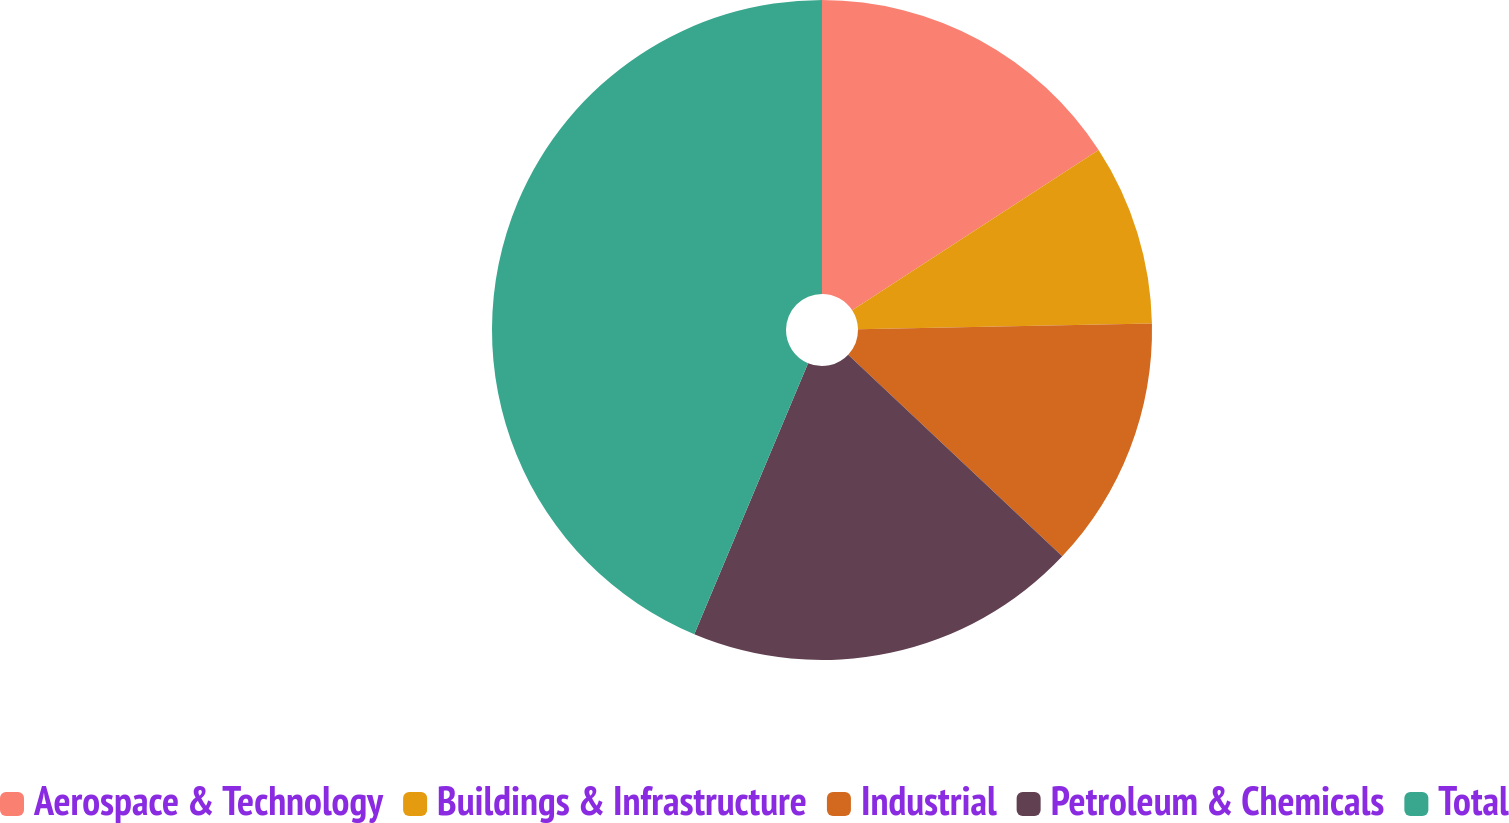<chart> <loc_0><loc_0><loc_500><loc_500><pie_chart><fcel>Aerospace & Technology<fcel>Buildings & Infrastructure<fcel>Industrial<fcel>Petroleum & Chemicals<fcel>Total<nl><fcel>15.82%<fcel>8.86%<fcel>12.34%<fcel>19.3%<fcel>43.67%<nl></chart> 